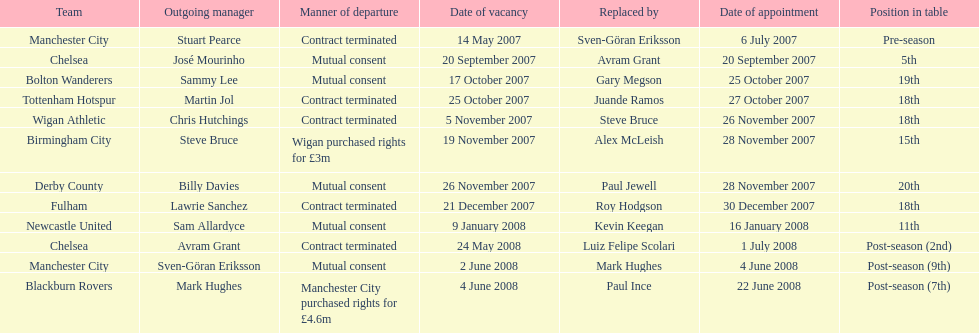In november 2007, how many managers were assigned to outgoing positions? 3. 